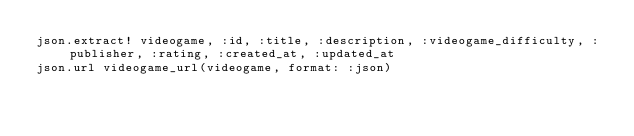Convert code to text. <code><loc_0><loc_0><loc_500><loc_500><_Ruby_>json.extract! videogame, :id, :title, :description, :videogame_difficulty, :publisher, :rating, :created_at, :updated_at
json.url videogame_url(videogame, format: :json)</code> 